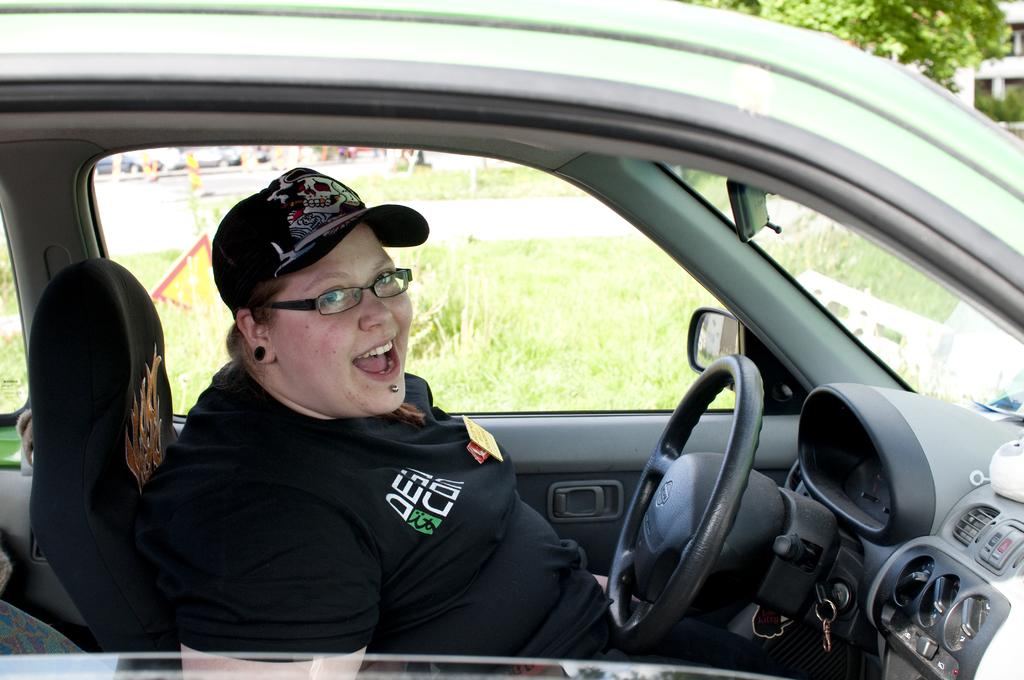What is the main subject of the image? There is a person in the image. What is the person wearing? The person is wearing a black dress. Where is the person located in the image? The person is sitting in a car. What can be seen in front of the person? There is a steering wheel in front of the person. What other objects can be seen in the background of the image? There are other objects visible in the background of the image. What type of mask is the person wearing in the image? There is no mask visible in the image; the person is wearing a black dress. What type of mine can be seen in the background of the image? There is no mine present in the image; the background contains other objects, but their nature is not specified. 